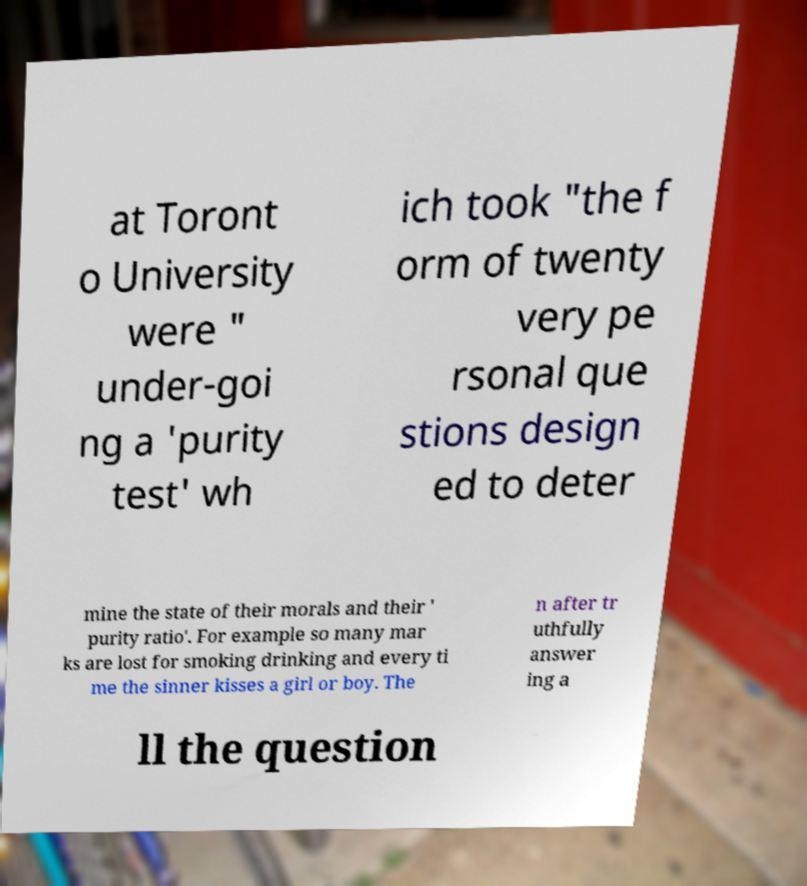Please identify and transcribe the text found in this image. at Toront o University were " under-goi ng a 'purity test' wh ich took "the f orm of twenty very pe rsonal que stions design ed to deter mine the state of their morals and their ' purity ratio'. For example so many mar ks are lost for smoking drinking and every ti me the sinner kisses a girl or boy. The n after tr uthfully answer ing a ll the question 